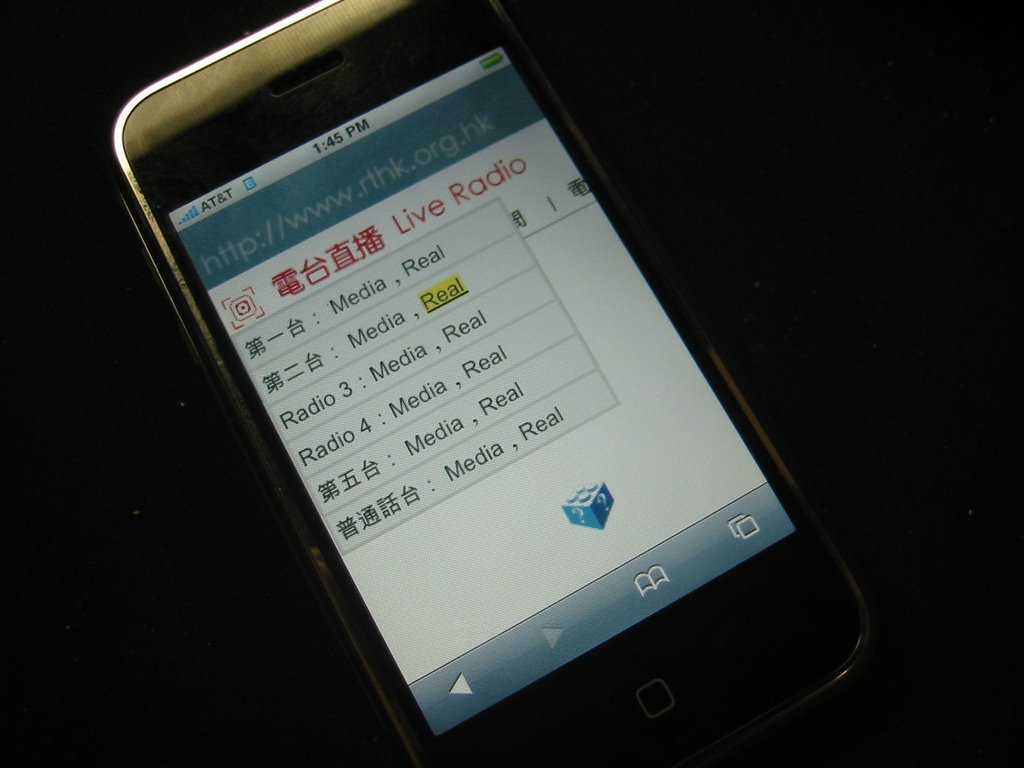Can you describe how the branding of AT&T is integrated into the device's interface as seen in the image? The branding of AT&T in the displayed image is subtly integrated, appearing only at the top left corner of the screen, indicating the network service without overwhelming the main content, which is focused on the radio service offerings. 